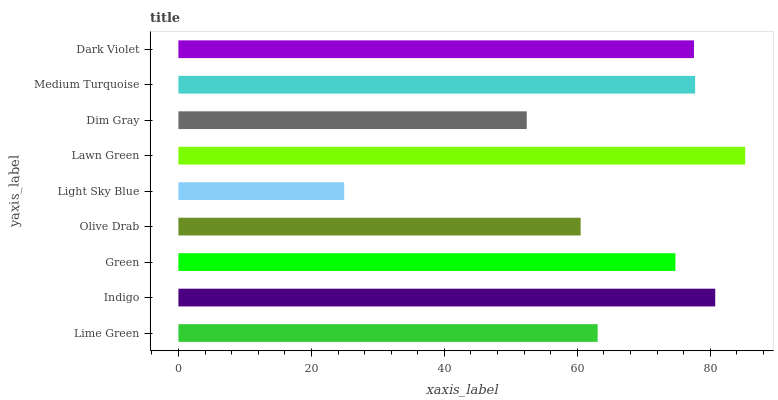Is Light Sky Blue the minimum?
Answer yes or no. Yes. Is Lawn Green the maximum?
Answer yes or no. Yes. Is Indigo the minimum?
Answer yes or no. No. Is Indigo the maximum?
Answer yes or no. No. Is Indigo greater than Lime Green?
Answer yes or no. Yes. Is Lime Green less than Indigo?
Answer yes or no. Yes. Is Lime Green greater than Indigo?
Answer yes or no. No. Is Indigo less than Lime Green?
Answer yes or no. No. Is Green the high median?
Answer yes or no. Yes. Is Green the low median?
Answer yes or no. Yes. Is Lawn Green the high median?
Answer yes or no. No. Is Dark Violet the low median?
Answer yes or no. No. 